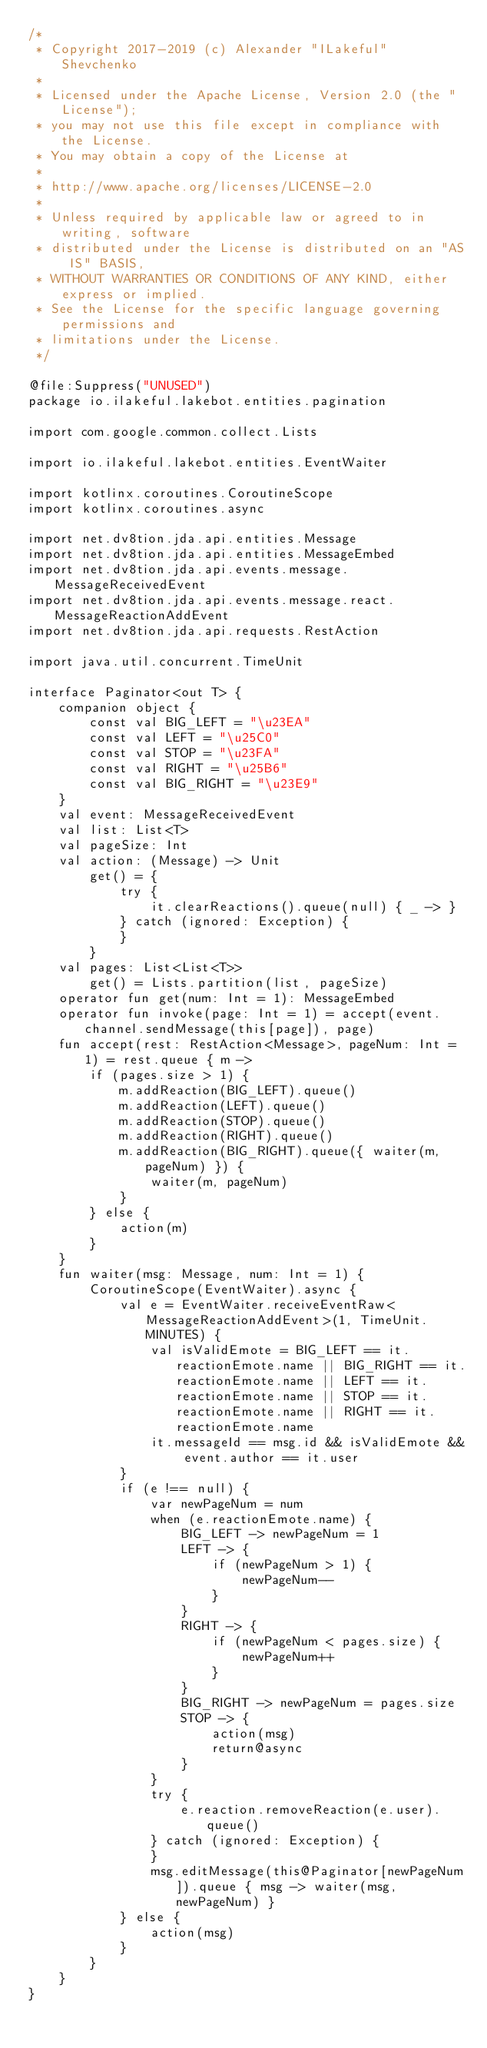<code> <loc_0><loc_0><loc_500><loc_500><_Kotlin_>/*
 * Copyright 2017-2019 (c) Alexander "ILakeful" Shevchenko
 *
 * Licensed under the Apache License, Version 2.0 (the "License");
 * you may not use this file except in compliance with the License.
 * You may obtain a copy of the License at
 *
 * http://www.apache.org/licenses/LICENSE-2.0
 *
 * Unless required by applicable law or agreed to in writing, software
 * distributed under the License is distributed on an "AS IS" BASIS,
 * WITHOUT WARRANTIES OR CONDITIONS OF ANY KIND, either express or implied.
 * See the License for the specific language governing permissions and
 * limitations under the License.
 */

@file:Suppress("UNUSED")
package io.ilakeful.lakebot.entities.pagination

import com.google.common.collect.Lists

import io.ilakeful.lakebot.entities.EventWaiter

import kotlinx.coroutines.CoroutineScope
import kotlinx.coroutines.async

import net.dv8tion.jda.api.entities.Message
import net.dv8tion.jda.api.entities.MessageEmbed
import net.dv8tion.jda.api.events.message.MessageReceivedEvent
import net.dv8tion.jda.api.events.message.react.MessageReactionAddEvent
import net.dv8tion.jda.api.requests.RestAction

import java.util.concurrent.TimeUnit

interface Paginator<out T> {
    companion object {
        const val BIG_LEFT = "\u23EA"
        const val LEFT = "\u25C0"
        const val STOP = "\u23FA"
        const val RIGHT = "\u25B6"
        const val BIG_RIGHT = "\u23E9"
    }
    val event: MessageReceivedEvent
    val list: List<T>
    val pageSize: Int
    val action: (Message) -> Unit
        get() = {
            try {
                it.clearReactions().queue(null) { _ -> }
            } catch (ignored: Exception) {
            }
        }
    val pages: List<List<T>>
        get() = Lists.partition(list, pageSize)
    operator fun get(num: Int = 1): MessageEmbed
    operator fun invoke(page: Int = 1) = accept(event.channel.sendMessage(this[page]), page)
    fun accept(rest: RestAction<Message>, pageNum: Int = 1) = rest.queue { m ->
        if (pages.size > 1) {
            m.addReaction(BIG_LEFT).queue()
            m.addReaction(LEFT).queue()
            m.addReaction(STOP).queue()
            m.addReaction(RIGHT).queue()
            m.addReaction(BIG_RIGHT).queue({ waiter(m, pageNum) }) {
                waiter(m, pageNum)
            }
        } else {
            action(m)
        }
    }
    fun waiter(msg: Message, num: Int = 1) {
        CoroutineScope(EventWaiter).async {
            val e = EventWaiter.receiveEventRaw<MessageReactionAddEvent>(1, TimeUnit.MINUTES) {
                val isValidEmote = BIG_LEFT == it.reactionEmote.name || BIG_RIGHT == it.reactionEmote.name || LEFT == it.reactionEmote.name || STOP == it.reactionEmote.name || RIGHT == it.reactionEmote.name
                it.messageId == msg.id && isValidEmote && event.author == it.user
            }
            if (e !== null) {
                var newPageNum = num
                when (e.reactionEmote.name) {
                    BIG_LEFT -> newPageNum = 1
                    LEFT -> {
                        if (newPageNum > 1) {
                            newPageNum--
                        }
                    }
                    RIGHT -> {
                        if (newPageNum < pages.size) {
                            newPageNum++
                        }
                    }
                    BIG_RIGHT -> newPageNum = pages.size
                    STOP -> {
                        action(msg)
                        return@async
                    }
                }
                try {
                    e.reaction.removeReaction(e.user).queue()
                } catch (ignored: Exception) {
                }
                msg.editMessage(this@Paginator[newPageNum]).queue { msg -> waiter(msg, newPageNum) }
            } else {
                action(msg)
            }
        }
    }
}</code> 